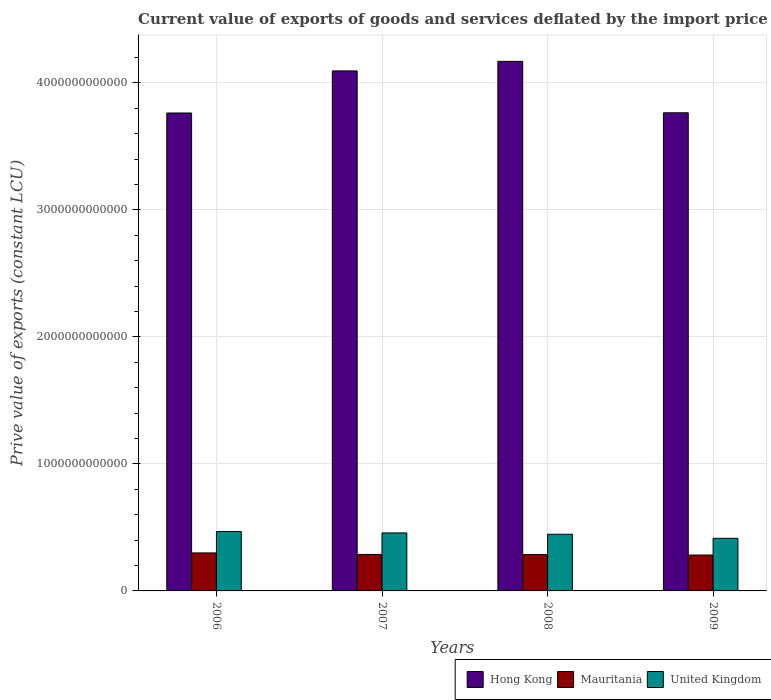How many different coloured bars are there?
Your response must be concise. 3. Are the number of bars per tick equal to the number of legend labels?
Your answer should be very brief. Yes. How many bars are there on the 3rd tick from the left?
Offer a very short reply. 3. In how many cases, is the number of bars for a given year not equal to the number of legend labels?
Provide a succinct answer. 0. What is the prive value of exports in Mauritania in 2009?
Your answer should be very brief. 2.83e+11. Across all years, what is the maximum prive value of exports in Hong Kong?
Your response must be concise. 4.17e+12. Across all years, what is the minimum prive value of exports in Mauritania?
Provide a succinct answer. 2.83e+11. What is the total prive value of exports in Mauritania in the graph?
Your answer should be very brief. 1.16e+12. What is the difference between the prive value of exports in United Kingdom in 2006 and that in 2009?
Your answer should be compact. 5.33e+1. What is the difference between the prive value of exports in Mauritania in 2009 and the prive value of exports in United Kingdom in 2006?
Ensure brevity in your answer.  -1.85e+11. What is the average prive value of exports in Hong Kong per year?
Provide a succinct answer. 3.95e+12. In the year 2006, what is the difference between the prive value of exports in United Kingdom and prive value of exports in Hong Kong?
Your answer should be very brief. -3.30e+12. In how many years, is the prive value of exports in United Kingdom greater than 1000000000000 LCU?
Give a very brief answer. 0. What is the ratio of the prive value of exports in United Kingdom in 2006 to that in 2008?
Keep it short and to the point. 1.05. Is the prive value of exports in United Kingdom in 2007 less than that in 2008?
Your answer should be very brief. No. What is the difference between the highest and the second highest prive value of exports in United Kingdom?
Keep it short and to the point. 1.08e+1. What is the difference between the highest and the lowest prive value of exports in Hong Kong?
Offer a terse response. 4.07e+11. In how many years, is the prive value of exports in United Kingdom greater than the average prive value of exports in United Kingdom taken over all years?
Offer a terse response. 3. What does the 2nd bar from the left in 2009 represents?
Keep it short and to the point. Mauritania. What does the 2nd bar from the right in 2008 represents?
Provide a succinct answer. Mauritania. Is it the case that in every year, the sum of the prive value of exports in United Kingdom and prive value of exports in Mauritania is greater than the prive value of exports in Hong Kong?
Ensure brevity in your answer.  No. How many bars are there?
Provide a short and direct response. 12. Are all the bars in the graph horizontal?
Your answer should be very brief. No. How many years are there in the graph?
Offer a very short reply. 4. What is the difference between two consecutive major ticks on the Y-axis?
Provide a succinct answer. 1.00e+12. Are the values on the major ticks of Y-axis written in scientific E-notation?
Your response must be concise. No. Does the graph contain any zero values?
Ensure brevity in your answer.  No. Does the graph contain grids?
Provide a succinct answer. Yes. How many legend labels are there?
Make the answer very short. 3. What is the title of the graph?
Offer a very short reply. Current value of exports of goods and services deflated by the import price index. What is the label or title of the Y-axis?
Offer a terse response. Prive value of exports (constant LCU). What is the Prive value of exports (constant LCU) of Hong Kong in 2006?
Make the answer very short. 3.76e+12. What is the Prive value of exports (constant LCU) of Mauritania in 2006?
Provide a short and direct response. 2.99e+11. What is the Prive value of exports (constant LCU) of United Kingdom in 2006?
Offer a very short reply. 4.67e+11. What is the Prive value of exports (constant LCU) of Hong Kong in 2007?
Keep it short and to the point. 4.09e+12. What is the Prive value of exports (constant LCU) of Mauritania in 2007?
Make the answer very short. 2.87e+11. What is the Prive value of exports (constant LCU) in United Kingdom in 2007?
Offer a very short reply. 4.57e+11. What is the Prive value of exports (constant LCU) of Hong Kong in 2008?
Offer a very short reply. 4.17e+12. What is the Prive value of exports (constant LCU) of Mauritania in 2008?
Provide a succinct answer. 2.86e+11. What is the Prive value of exports (constant LCU) of United Kingdom in 2008?
Your response must be concise. 4.46e+11. What is the Prive value of exports (constant LCU) of Hong Kong in 2009?
Your response must be concise. 3.77e+12. What is the Prive value of exports (constant LCU) in Mauritania in 2009?
Provide a short and direct response. 2.83e+11. What is the Prive value of exports (constant LCU) of United Kingdom in 2009?
Offer a very short reply. 4.14e+11. Across all years, what is the maximum Prive value of exports (constant LCU) in Hong Kong?
Your answer should be compact. 4.17e+12. Across all years, what is the maximum Prive value of exports (constant LCU) of Mauritania?
Your answer should be very brief. 2.99e+11. Across all years, what is the maximum Prive value of exports (constant LCU) of United Kingdom?
Give a very brief answer. 4.67e+11. Across all years, what is the minimum Prive value of exports (constant LCU) of Hong Kong?
Keep it short and to the point. 3.76e+12. Across all years, what is the minimum Prive value of exports (constant LCU) of Mauritania?
Keep it short and to the point. 2.83e+11. Across all years, what is the minimum Prive value of exports (constant LCU) of United Kingdom?
Offer a very short reply. 4.14e+11. What is the total Prive value of exports (constant LCU) of Hong Kong in the graph?
Provide a succinct answer. 1.58e+13. What is the total Prive value of exports (constant LCU) of Mauritania in the graph?
Your answer should be very brief. 1.16e+12. What is the total Prive value of exports (constant LCU) of United Kingdom in the graph?
Your answer should be very brief. 1.78e+12. What is the difference between the Prive value of exports (constant LCU) of Hong Kong in 2006 and that in 2007?
Provide a short and direct response. -3.31e+11. What is the difference between the Prive value of exports (constant LCU) of Mauritania in 2006 and that in 2007?
Offer a terse response. 1.21e+1. What is the difference between the Prive value of exports (constant LCU) of United Kingdom in 2006 and that in 2007?
Make the answer very short. 1.08e+1. What is the difference between the Prive value of exports (constant LCU) in Hong Kong in 2006 and that in 2008?
Your response must be concise. -4.07e+11. What is the difference between the Prive value of exports (constant LCU) of Mauritania in 2006 and that in 2008?
Make the answer very short. 1.33e+1. What is the difference between the Prive value of exports (constant LCU) of United Kingdom in 2006 and that in 2008?
Provide a short and direct response. 2.11e+1. What is the difference between the Prive value of exports (constant LCU) in Hong Kong in 2006 and that in 2009?
Keep it short and to the point. -1.61e+09. What is the difference between the Prive value of exports (constant LCU) in Mauritania in 2006 and that in 2009?
Your answer should be very brief. 1.67e+1. What is the difference between the Prive value of exports (constant LCU) of United Kingdom in 2006 and that in 2009?
Ensure brevity in your answer.  5.33e+1. What is the difference between the Prive value of exports (constant LCU) in Hong Kong in 2007 and that in 2008?
Give a very brief answer. -7.53e+1. What is the difference between the Prive value of exports (constant LCU) of Mauritania in 2007 and that in 2008?
Offer a very short reply. 1.15e+09. What is the difference between the Prive value of exports (constant LCU) in United Kingdom in 2007 and that in 2008?
Provide a succinct answer. 1.03e+1. What is the difference between the Prive value of exports (constant LCU) of Hong Kong in 2007 and that in 2009?
Your answer should be compact. 3.30e+11. What is the difference between the Prive value of exports (constant LCU) in Mauritania in 2007 and that in 2009?
Offer a very short reply. 4.63e+09. What is the difference between the Prive value of exports (constant LCU) in United Kingdom in 2007 and that in 2009?
Keep it short and to the point. 4.25e+1. What is the difference between the Prive value of exports (constant LCU) of Hong Kong in 2008 and that in 2009?
Your response must be concise. 4.05e+11. What is the difference between the Prive value of exports (constant LCU) in Mauritania in 2008 and that in 2009?
Offer a terse response. 3.48e+09. What is the difference between the Prive value of exports (constant LCU) in United Kingdom in 2008 and that in 2009?
Give a very brief answer. 3.22e+1. What is the difference between the Prive value of exports (constant LCU) in Hong Kong in 2006 and the Prive value of exports (constant LCU) in Mauritania in 2007?
Keep it short and to the point. 3.48e+12. What is the difference between the Prive value of exports (constant LCU) in Hong Kong in 2006 and the Prive value of exports (constant LCU) in United Kingdom in 2007?
Your response must be concise. 3.31e+12. What is the difference between the Prive value of exports (constant LCU) in Mauritania in 2006 and the Prive value of exports (constant LCU) in United Kingdom in 2007?
Your answer should be very brief. -1.57e+11. What is the difference between the Prive value of exports (constant LCU) of Hong Kong in 2006 and the Prive value of exports (constant LCU) of Mauritania in 2008?
Offer a very short reply. 3.48e+12. What is the difference between the Prive value of exports (constant LCU) of Hong Kong in 2006 and the Prive value of exports (constant LCU) of United Kingdom in 2008?
Offer a terse response. 3.32e+12. What is the difference between the Prive value of exports (constant LCU) of Mauritania in 2006 and the Prive value of exports (constant LCU) of United Kingdom in 2008?
Provide a succinct answer. -1.47e+11. What is the difference between the Prive value of exports (constant LCU) in Hong Kong in 2006 and the Prive value of exports (constant LCU) in Mauritania in 2009?
Your response must be concise. 3.48e+12. What is the difference between the Prive value of exports (constant LCU) in Hong Kong in 2006 and the Prive value of exports (constant LCU) in United Kingdom in 2009?
Your answer should be compact. 3.35e+12. What is the difference between the Prive value of exports (constant LCU) in Mauritania in 2006 and the Prive value of exports (constant LCU) in United Kingdom in 2009?
Ensure brevity in your answer.  -1.15e+11. What is the difference between the Prive value of exports (constant LCU) in Hong Kong in 2007 and the Prive value of exports (constant LCU) in Mauritania in 2008?
Offer a terse response. 3.81e+12. What is the difference between the Prive value of exports (constant LCU) in Hong Kong in 2007 and the Prive value of exports (constant LCU) in United Kingdom in 2008?
Ensure brevity in your answer.  3.65e+12. What is the difference between the Prive value of exports (constant LCU) of Mauritania in 2007 and the Prive value of exports (constant LCU) of United Kingdom in 2008?
Make the answer very short. -1.59e+11. What is the difference between the Prive value of exports (constant LCU) of Hong Kong in 2007 and the Prive value of exports (constant LCU) of Mauritania in 2009?
Provide a short and direct response. 3.81e+12. What is the difference between the Prive value of exports (constant LCU) in Hong Kong in 2007 and the Prive value of exports (constant LCU) in United Kingdom in 2009?
Provide a short and direct response. 3.68e+12. What is the difference between the Prive value of exports (constant LCU) in Mauritania in 2007 and the Prive value of exports (constant LCU) in United Kingdom in 2009?
Offer a terse response. -1.27e+11. What is the difference between the Prive value of exports (constant LCU) of Hong Kong in 2008 and the Prive value of exports (constant LCU) of Mauritania in 2009?
Provide a succinct answer. 3.89e+12. What is the difference between the Prive value of exports (constant LCU) in Hong Kong in 2008 and the Prive value of exports (constant LCU) in United Kingdom in 2009?
Keep it short and to the point. 3.76e+12. What is the difference between the Prive value of exports (constant LCU) of Mauritania in 2008 and the Prive value of exports (constant LCU) of United Kingdom in 2009?
Provide a succinct answer. -1.28e+11. What is the average Prive value of exports (constant LCU) of Hong Kong per year?
Give a very brief answer. 3.95e+12. What is the average Prive value of exports (constant LCU) in Mauritania per year?
Give a very brief answer. 2.89e+11. What is the average Prive value of exports (constant LCU) in United Kingdom per year?
Provide a succinct answer. 4.46e+11. In the year 2006, what is the difference between the Prive value of exports (constant LCU) in Hong Kong and Prive value of exports (constant LCU) in Mauritania?
Ensure brevity in your answer.  3.46e+12. In the year 2006, what is the difference between the Prive value of exports (constant LCU) of Hong Kong and Prive value of exports (constant LCU) of United Kingdom?
Your response must be concise. 3.30e+12. In the year 2006, what is the difference between the Prive value of exports (constant LCU) of Mauritania and Prive value of exports (constant LCU) of United Kingdom?
Your answer should be very brief. -1.68e+11. In the year 2007, what is the difference between the Prive value of exports (constant LCU) of Hong Kong and Prive value of exports (constant LCU) of Mauritania?
Offer a terse response. 3.81e+12. In the year 2007, what is the difference between the Prive value of exports (constant LCU) in Hong Kong and Prive value of exports (constant LCU) in United Kingdom?
Offer a terse response. 3.64e+12. In the year 2007, what is the difference between the Prive value of exports (constant LCU) of Mauritania and Prive value of exports (constant LCU) of United Kingdom?
Your answer should be compact. -1.70e+11. In the year 2008, what is the difference between the Prive value of exports (constant LCU) in Hong Kong and Prive value of exports (constant LCU) in Mauritania?
Provide a short and direct response. 3.88e+12. In the year 2008, what is the difference between the Prive value of exports (constant LCU) in Hong Kong and Prive value of exports (constant LCU) in United Kingdom?
Keep it short and to the point. 3.72e+12. In the year 2008, what is the difference between the Prive value of exports (constant LCU) in Mauritania and Prive value of exports (constant LCU) in United Kingdom?
Your response must be concise. -1.60e+11. In the year 2009, what is the difference between the Prive value of exports (constant LCU) of Hong Kong and Prive value of exports (constant LCU) of Mauritania?
Ensure brevity in your answer.  3.48e+12. In the year 2009, what is the difference between the Prive value of exports (constant LCU) of Hong Kong and Prive value of exports (constant LCU) of United Kingdom?
Your response must be concise. 3.35e+12. In the year 2009, what is the difference between the Prive value of exports (constant LCU) in Mauritania and Prive value of exports (constant LCU) in United Kingdom?
Your answer should be very brief. -1.32e+11. What is the ratio of the Prive value of exports (constant LCU) of Hong Kong in 2006 to that in 2007?
Give a very brief answer. 0.92. What is the ratio of the Prive value of exports (constant LCU) in Mauritania in 2006 to that in 2007?
Your answer should be compact. 1.04. What is the ratio of the Prive value of exports (constant LCU) of United Kingdom in 2006 to that in 2007?
Offer a terse response. 1.02. What is the ratio of the Prive value of exports (constant LCU) of Hong Kong in 2006 to that in 2008?
Your answer should be compact. 0.9. What is the ratio of the Prive value of exports (constant LCU) in Mauritania in 2006 to that in 2008?
Provide a short and direct response. 1.05. What is the ratio of the Prive value of exports (constant LCU) of United Kingdom in 2006 to that in 2008?
Make the answer very short. 1.05. What is the ratio of the Prive value of exports (constant LCU) of Mauritania in 2006 to that in 2009?
Your answer should be very brief. 1.06. What is the ratio of the Prive value of exports (constant LCU) in United Kingdom in 2006 to that in 2009?
Your answer should be very brief. 1.13. What is the ratio of the Prive value of exports (constant LCU) in Hong Kong in 2007 to that in 2008?
Ensure brevity in your answer.  0.98. What is the ratio of the Prive value of exports (constant LCU) in United Kingdom in 2007 to that in 2008?
Your response must be concise. 1.02. What is the ratio of the Prive value of exports (constant LCU) in Hong Kong in 2007 to that in 2009?
Your answer should be very brief. 1.09. What is the ratio of the Prive value of exports (constant LCU) of Mauritania in 2007 to that in 2009?
Give a very brief answer. 1.02. What is the ratio of the Prive value of exports (constant LCU) of United Kingdom in 2007 to that in 2009?
Your answer should be compact. 1.1. What is the ratio of the Prive value of exports (constant LCU) of Hong Kong in 2008 to that in 2009?
Provide a succinct answer. 1.11. What is the ratio of the Prive value of exports (constant LCU) of Mauritania in 2008 to that in 2009?
Offer a terse response. 1.01. What is the ratio of the Prive value of exports (constant LCU) of United Kingdom in 2008 to that in 2009?
Offer a terse response. 1.08. What is the difference between the highest and the second highest Prive value of exports (constant LCU) of Hong Kong?
Your answer should be compact. 7.53e+1. What is the difference between the highest and the second highest Prive value of exports (constant LCU) in Mauritania?
Offer a terse response. 1.21e+1. What is the difference between the highest and the second highest Prive value of exports (constant LCU) in United Kingdom?
Provide a succinct answer. 1.08e+1. What is the difference between the highest and the lowest Prive value of exports (constant LCU) of Hong Kong?
Provide a short and direct response. 4.07e+11. What is the difference between the highest and the lowest Prive value of exports (constant LCU) of Mauritania?
Provide a short and direct response. 1.67e+1. What is the difference between the highest and the lowest Prive value of exports (constant LCU) of United Kingdom?
Provide a succinct answer. 5.33e+1. 